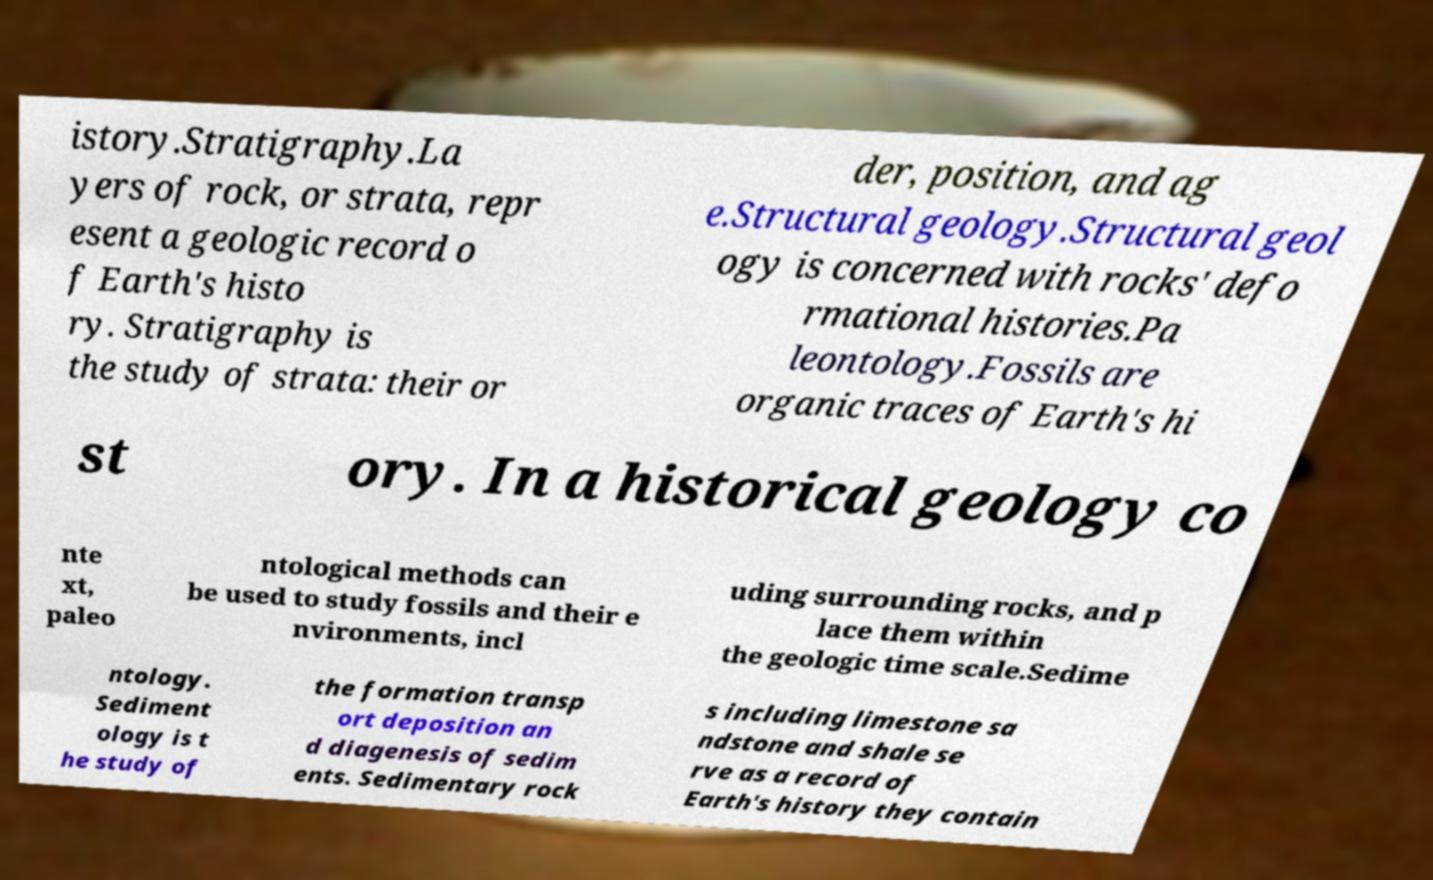Can you accurately transcribe the text from the provided image for me? istory.Stratigraphy.La yers of rock, or strata, repr esent a geologic record o f Earth's histo ry. Stratigraphy is the study of strata: their or der, position, and ag e.Structural geology.Structural geol ogy is concerned with rocks' defo rmational histories.Pa leontology.Fossils are organic traces of Earth's hi st ory. In a historical geology co nte xt, paleo ntological methods can be used to study fossils and their e nvironments, incl uding surrounding rocks, and p lace them within the geologic time scale.Sedime ntology. Sediment ology is t he study of the formation transp ort deposition an d diagenesis of sedim ents. Sedimentary rock s including limestone sa ndstone and shale se rve as a record of Earth's history they contain 